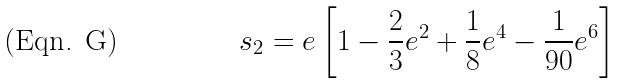Convert formula to latex. <formula><loc_0><loc_0><loc_500><loc_500>s _ { 2 } = e \left [ 1 - \frac { 2 } { 3 } e ^ { 2 } + \frac { 1 } { 8 } e ^ { 4 } - \frac { 1 } { 9 0 } e ^ { 6 } \right ]</formula> 